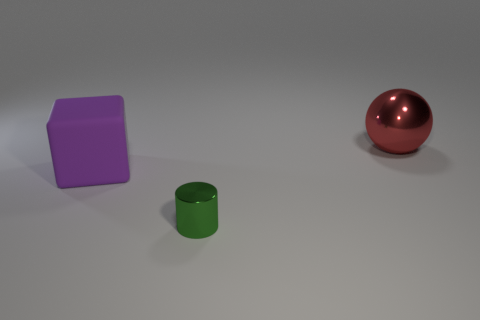Subtract all balls. How many objects are left? 2 Add 1 tiny cyan rubber cubes. How many objects exist? 4 Subtract 1 cylinders. How many cylinders are left? 0 Subtract all red cubes. Subtract all purple cylinders. How many cubes are left? 1 Subtract all red objects. Subtract all big purple matte objects. How many objects are left? 1 Add 2 green things. How many green things are left? 3 Add 3 rubber cubes. How many rubber cubes exist? 4 Subtract 0 red cylinders. How many objects are left? 3 